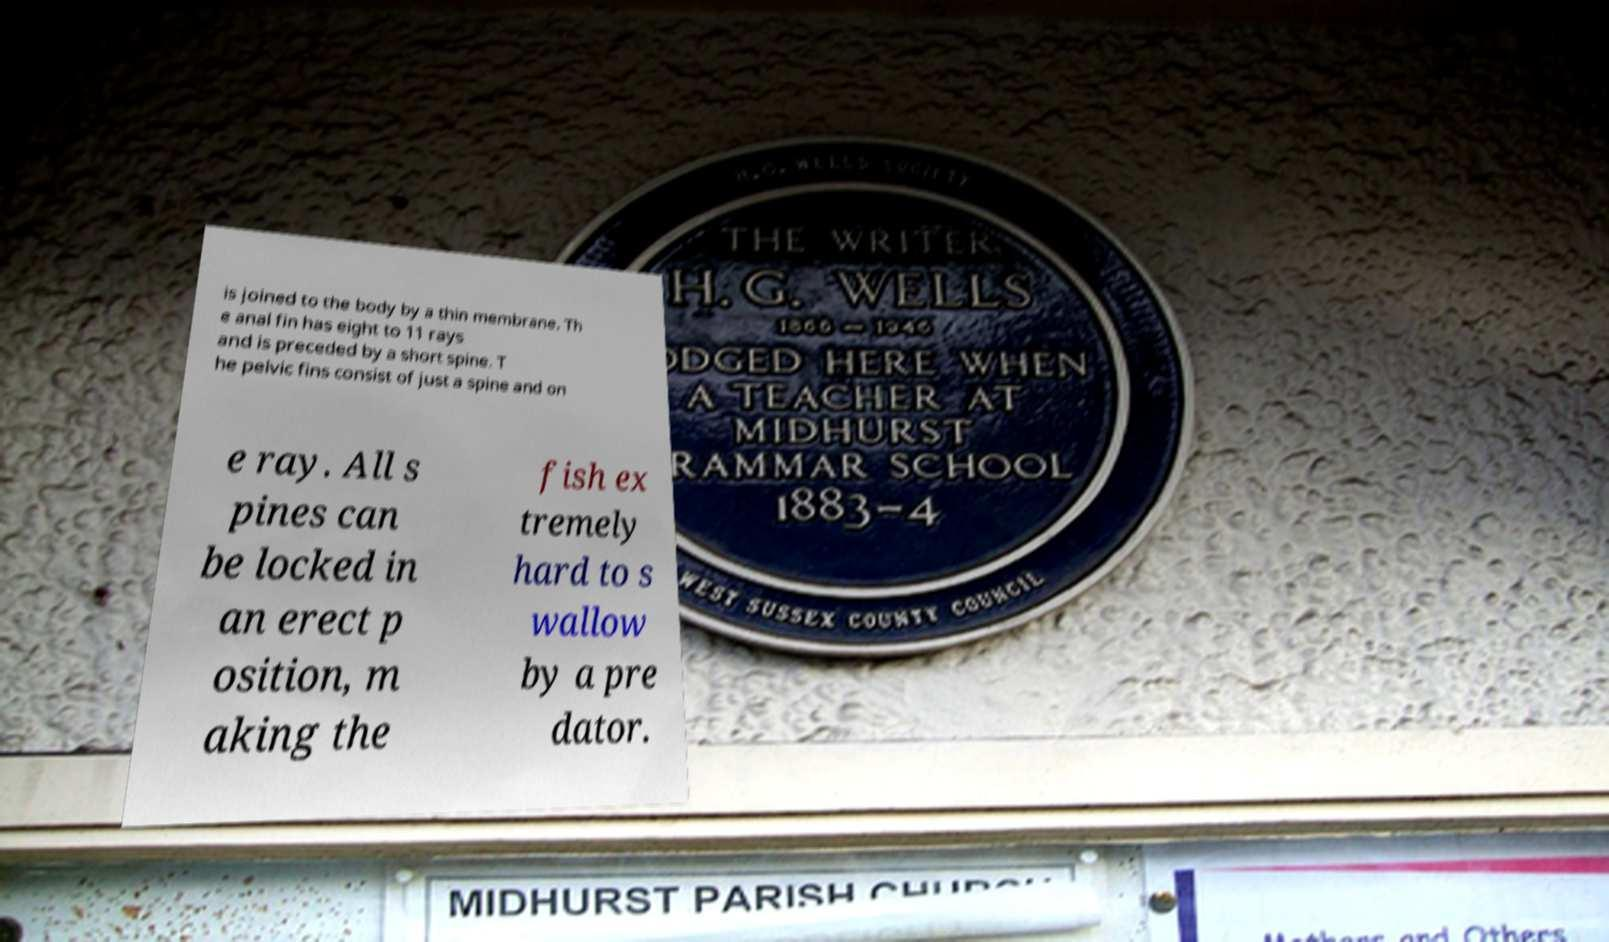Can you accurately transcribe the text from the provided image for me? is joined to the body by a thin membrane. Th e anal fin has eight to 11 rays and is preceded by a short spine. T he pelvic fins consist of just a spine and on e ray. All s pines can be locked in an erect p osition, m aking the fish ex tremely hard to s wallow by a pre dator. 